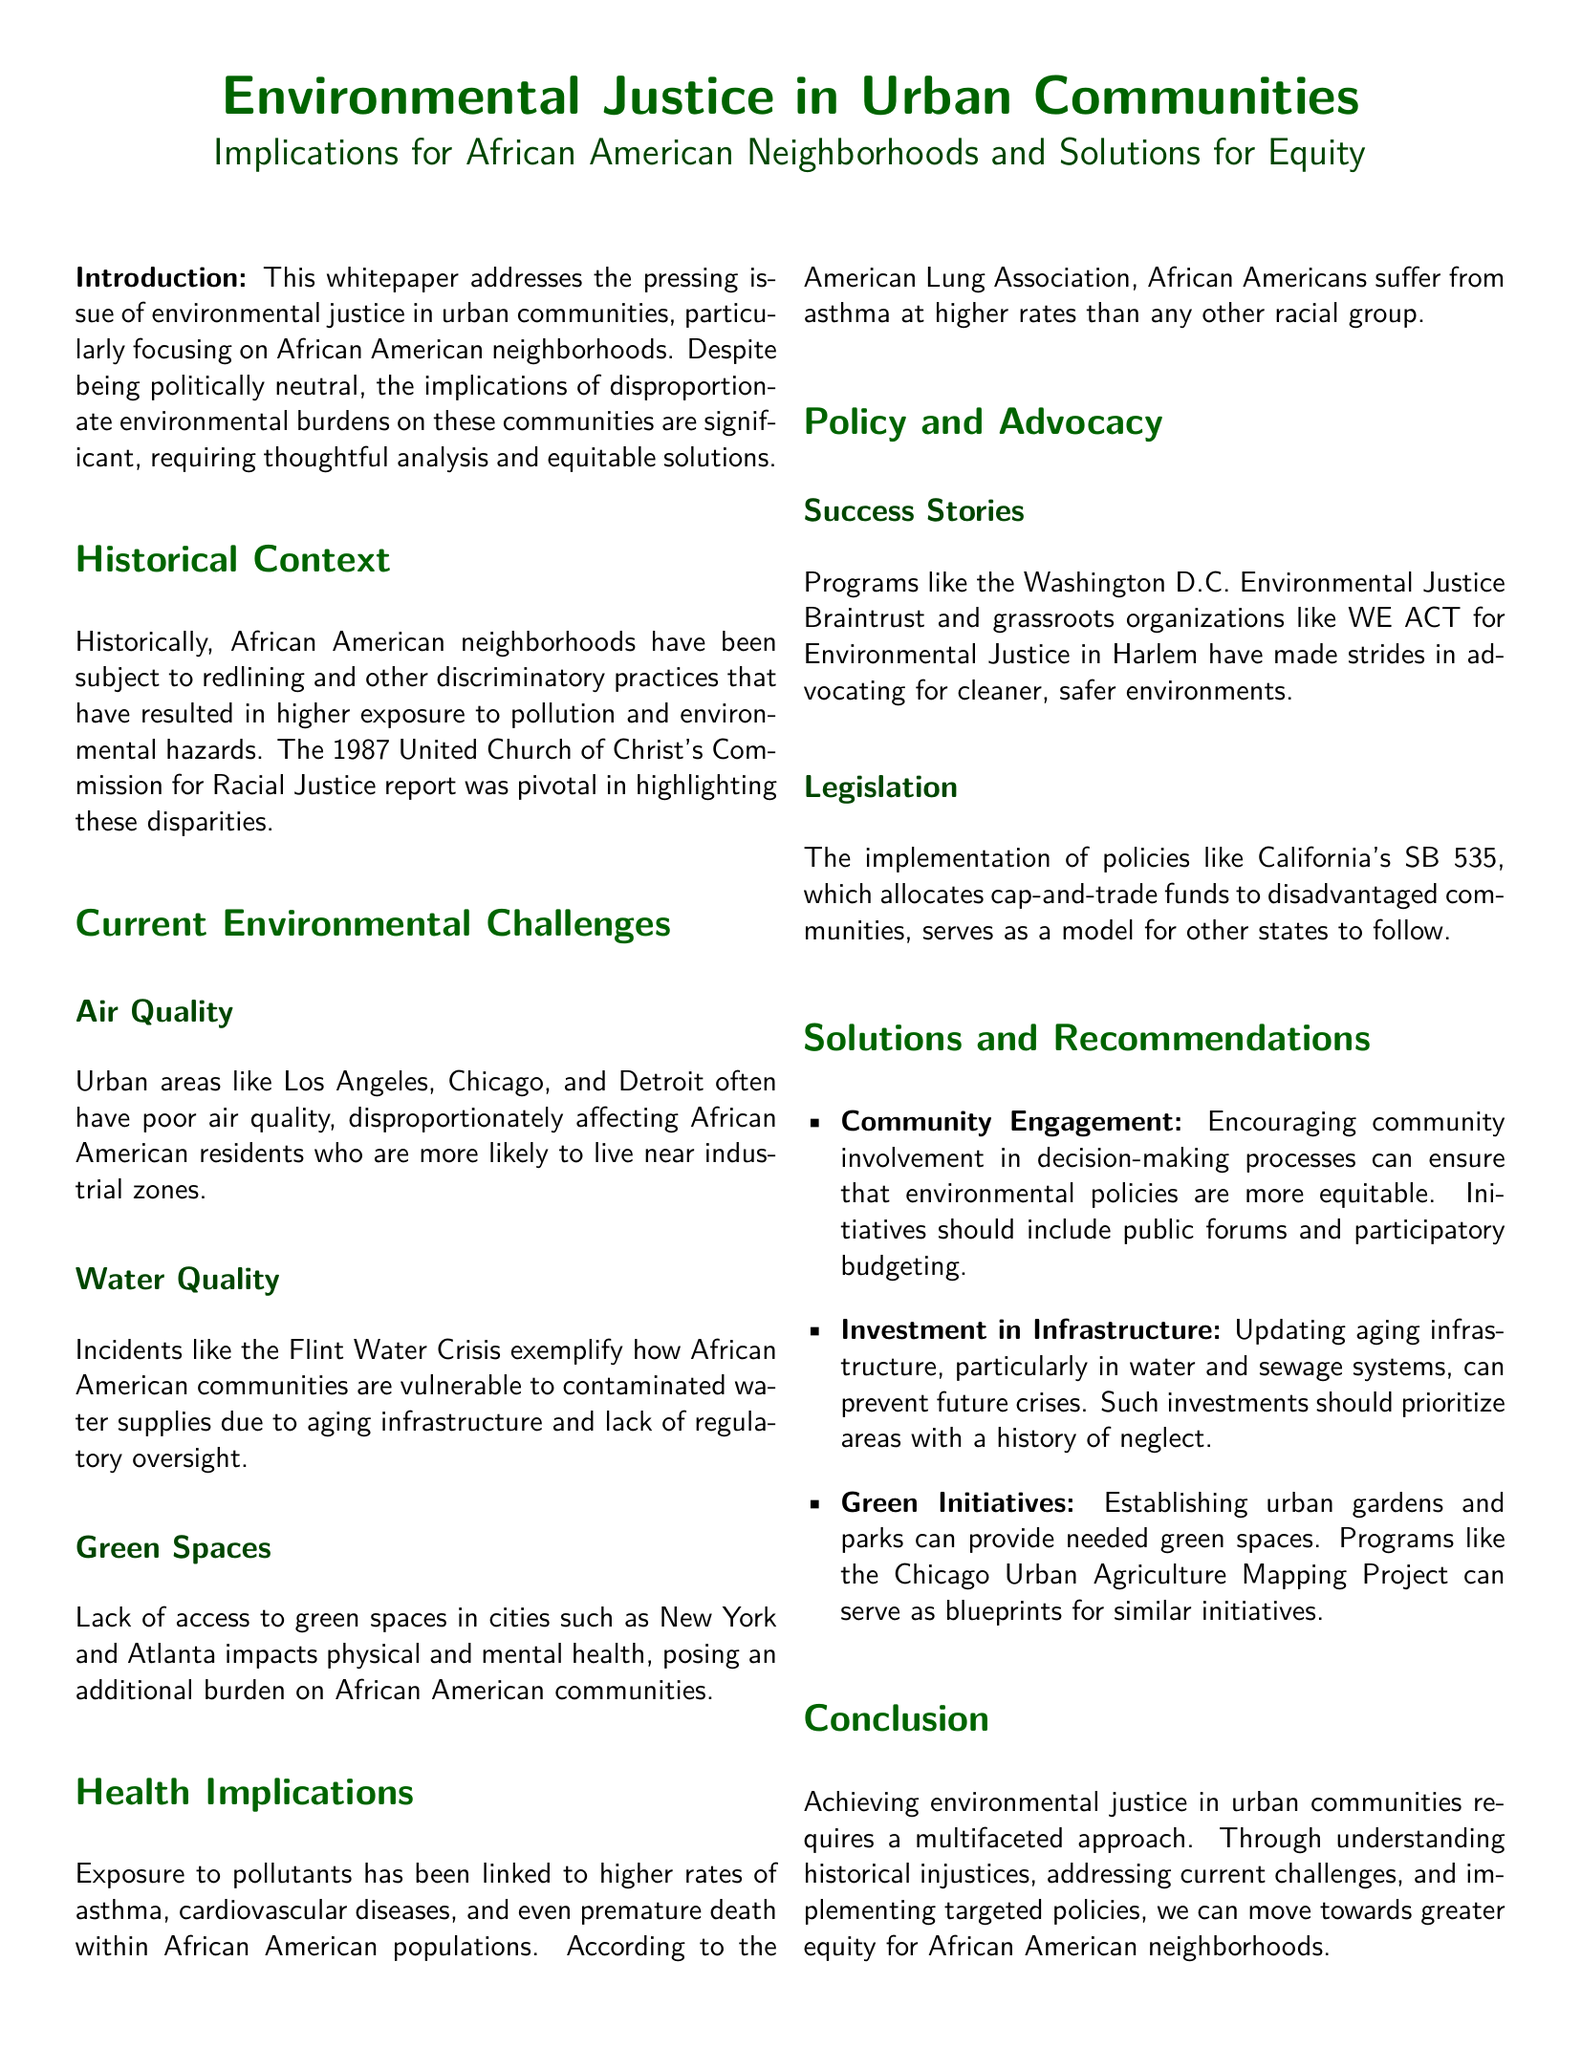What report highlighted environmental disparities? The report by the United Church of Christ's Commission for Racial Justice in 1987 highlighted these disparities.
Answer: 1987 United Church of Christ's Commission for Racial Justice report What major urban area is mentioned for poor air quality? Los Angeles is mentioned as one of the urban areas often having poor air quality.
Answer: Los Angeles What incident exemplifies vulnerability to contaminated water supplies? The Flint Water Crisis exemplifies this vulnerability.
Answer: Flint Water Crisis What is a result of exposure to pollutants in African American populations? Exposure to pollutants has been linked to higher rates of asthma.
Answer: Higher rates of asthma What type of community initiative is recommended for equity? Community engagement in decision-making processes is recommended.
Answer: Community engagement Which legislation allocates cap-and-trade funds to disadvantaged communities? California's SB 535 allocates cap-and-trade funds.
Answer: SB 535 Name a city where lack of green spaces impacts health. New York is mentioned as a city lacking green spaces.
Answer: New York What organization works for environmental justice in Harlem? WE ACT for Environmental Justice works in Harlem.
Answer: WE ACT for Environmental Justice 